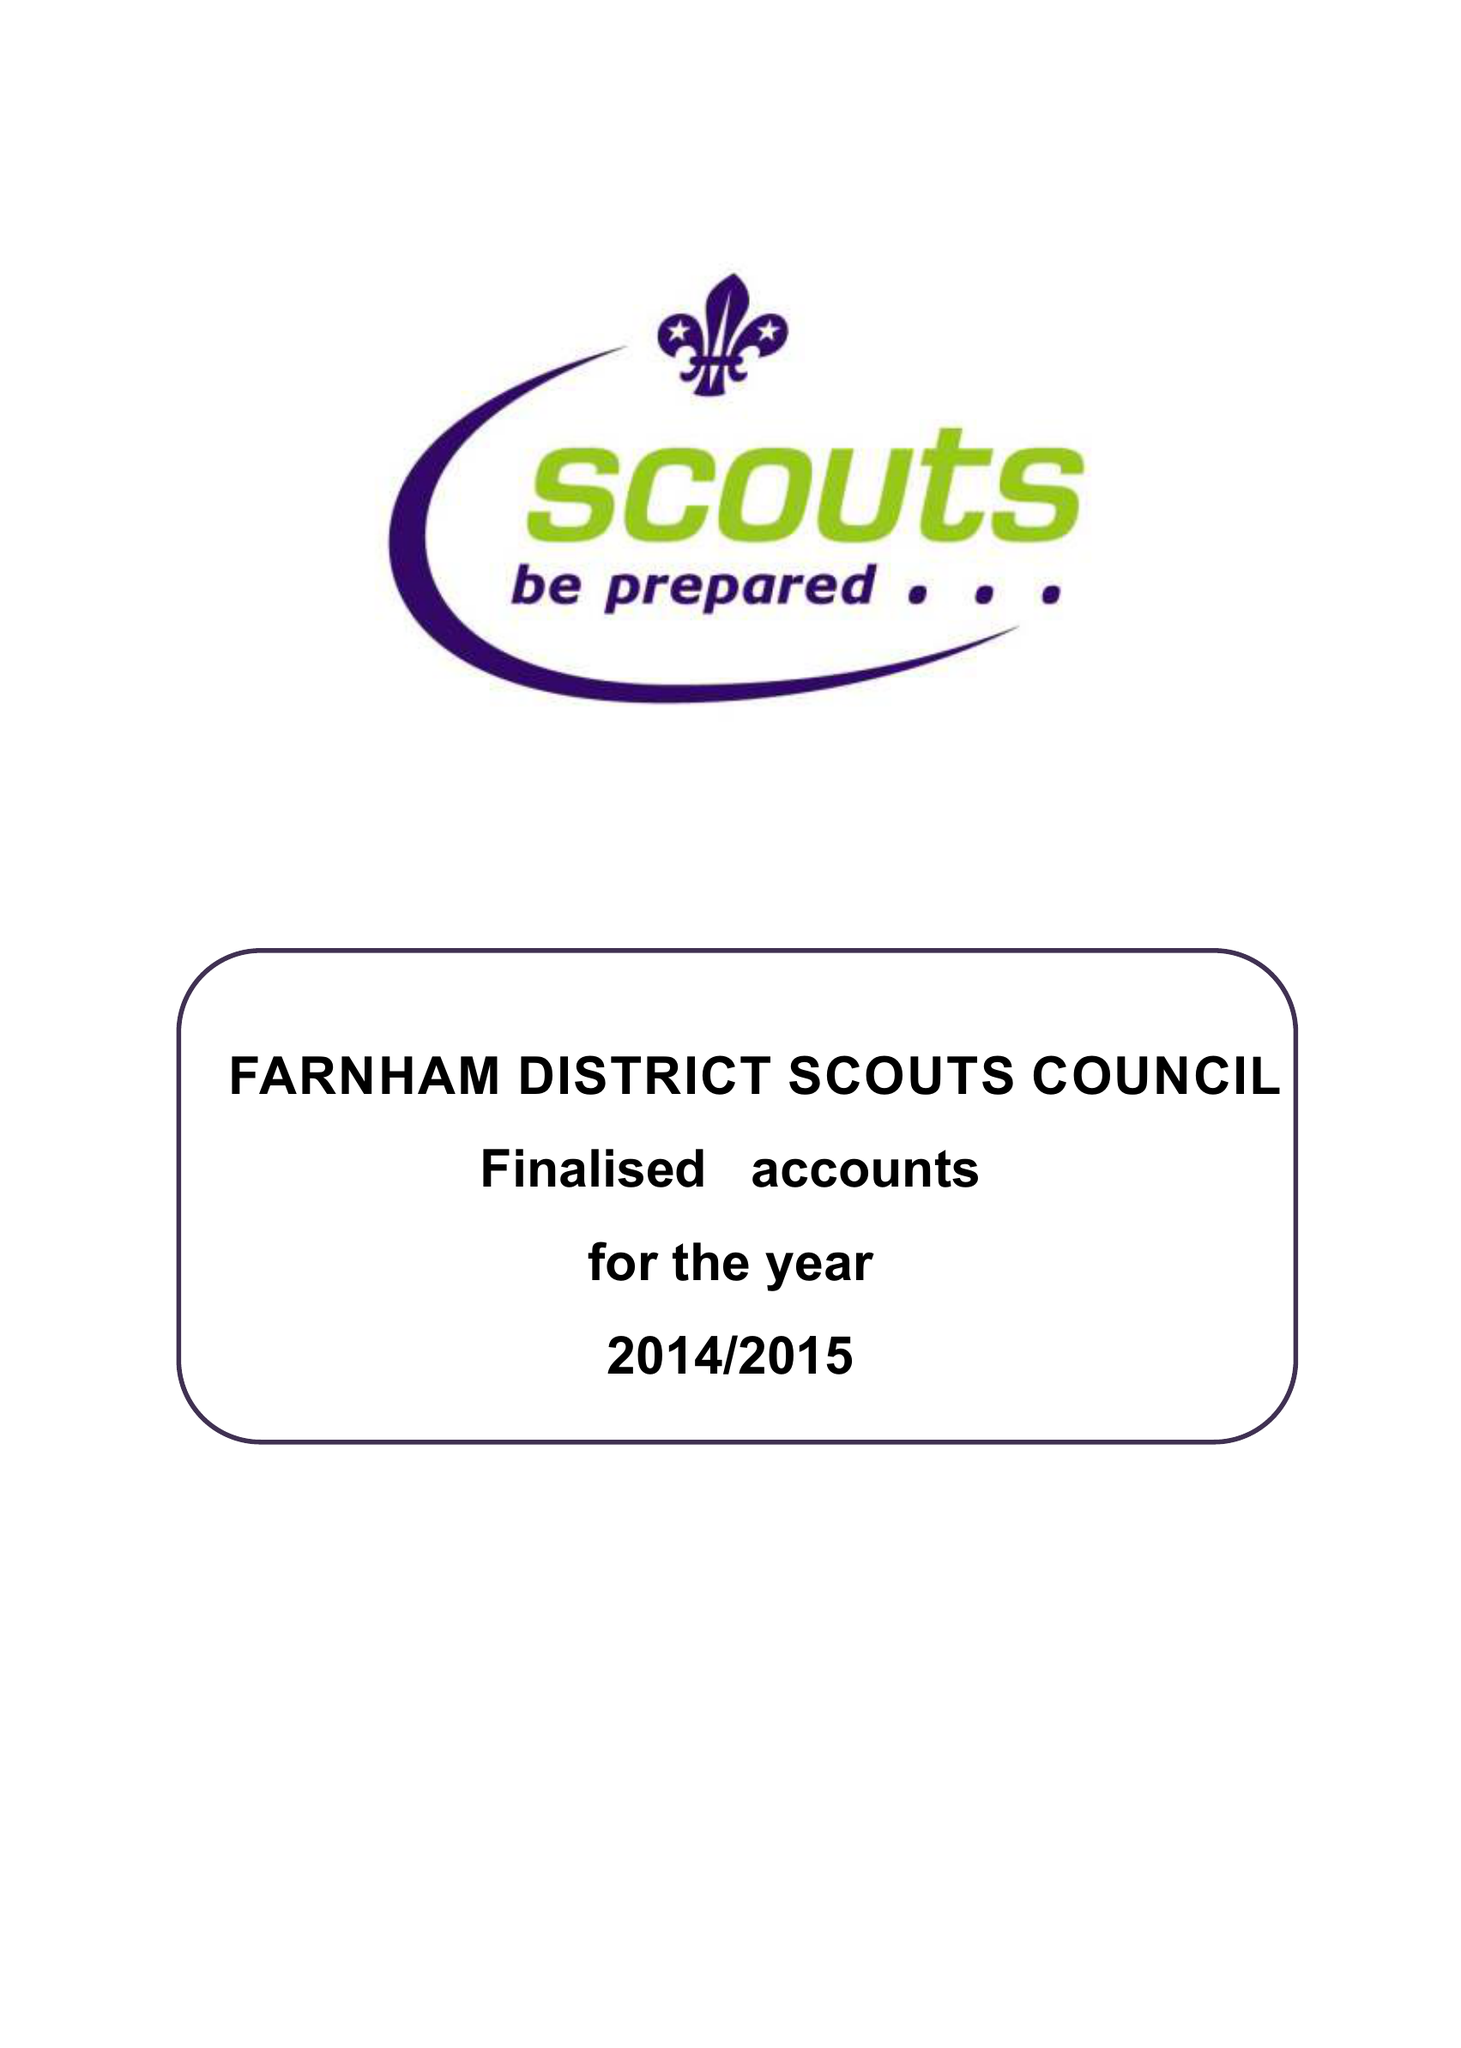What is the value for the address__postcode?
Answer the question using a single word or phrase. GU9 0PE 